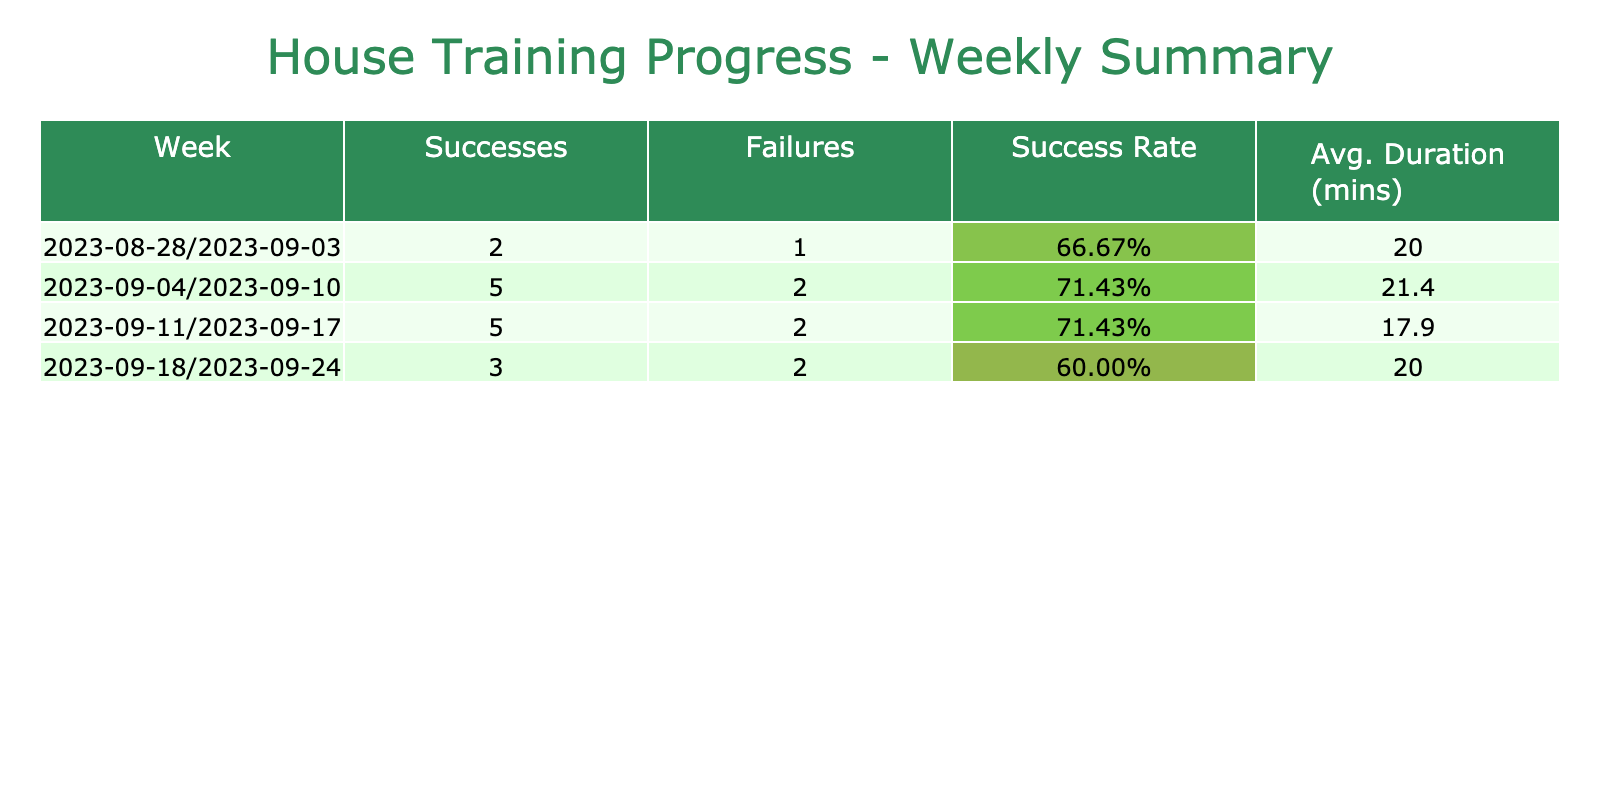What is the total number of successful house training sessions? To find the total number of successful house training sessions, we add up the "Success" column for all weeks. The values are 5 (Week 1) + 5 (Week 2) + 4 (Week 3) + 3 (Week 4) = 17.
Answer: 17 What is the average duration of successful sessions? We need to consider only the rows where success is 1. The total time for successful sessions is calculated and divided by the number of successful sessions. The total duration is (15 + 20 + 10 + 20 + 25 + 15 + 10 + 20 + 35)/9 = 19.44 minutes. After rounding to one decimal place, the average is approximately 19.4 minutes.
Answer: 19.4 minutes How many sessions failed in the last week? In the last week, we look at the values in the "Failure" column for Week 4. There are 3 failures recorded.
Answer: 3 What is the success rate for the second week? To calculate the success rate for the second week, we take the number of successful sessions (5) and divide by the total number of sessions (5 + 1 = 6), which equals 5/6, or approximately 83.33%. When expressed in percentage, the success rate is 83.33%.
Answer: 83.33% Was the success rate for any week below 50%? We need to examine the success rates for each week. The success rates calculated are: Week 1 (83.33%), Week 2 (83.33%), Week 3 (40%), and Week 4 (60%). Since Week 3 has a success rate of 40%, the answer is yes.
Answer: Yes What is the total number of sessions conducted in Week 3? In Week 3, we review the data for sessions. There are 10 sessions listed, which consist of 4 successes and 6 failures making the total count 10.
Answer: 10 What was the highest success rate across all weeks? To find the highest success rate, we review the success rates calculated for each week: Week 1 (83.33%), Week 2 (83.33%), Week 3 (40%), and Week 4 (60%). The maximum value among these rates is 83.33%.
Answer: 83.33% How many more successful sessions were there in Week 1 than in Week 4? We look up the successful sessions for Week 1 (5) and Week 4 (3). Calculating the difference gives us 5 - 3 = 2 more successful sessions in Week 1 than in Week 4.
Answer: 2 